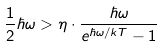<formula> <loc_0><loc_0><loc_500><loc_500>\frac { 1 } { 2 } \hbar { \omega } > \eta \cdot \frac { \hbar { \omega } } { e ^ { \hbar { \omega } / k T } - 1 }</formula> 